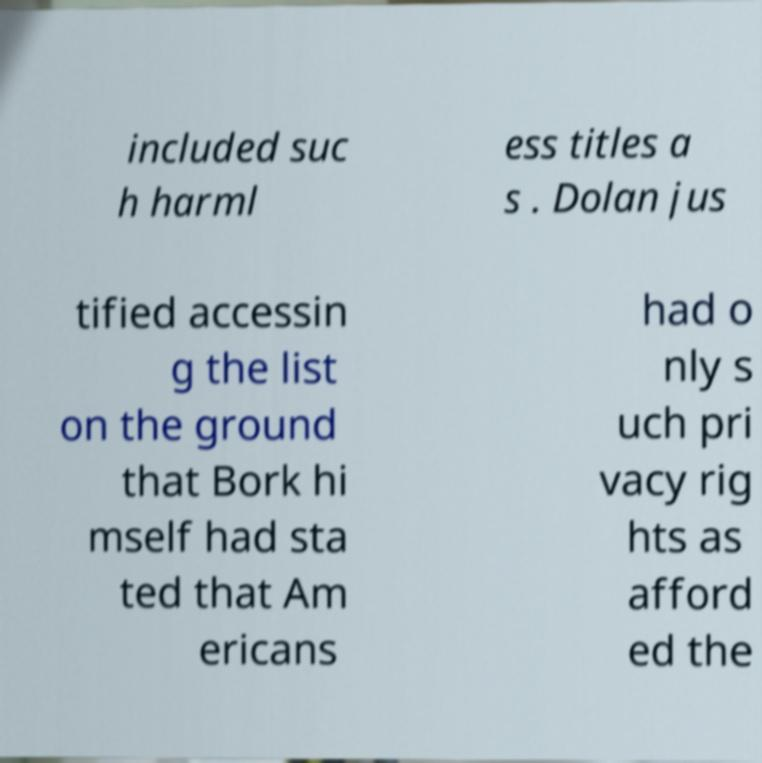Please read and relay the text visible in this image. What does it say? included suc h harml ess titles a s . Dolan jus tified accessin g the list on the ground that Bork hi mself had sta ted that Am ericans had o nly s uch pri vacy rig hts as afford ed the 